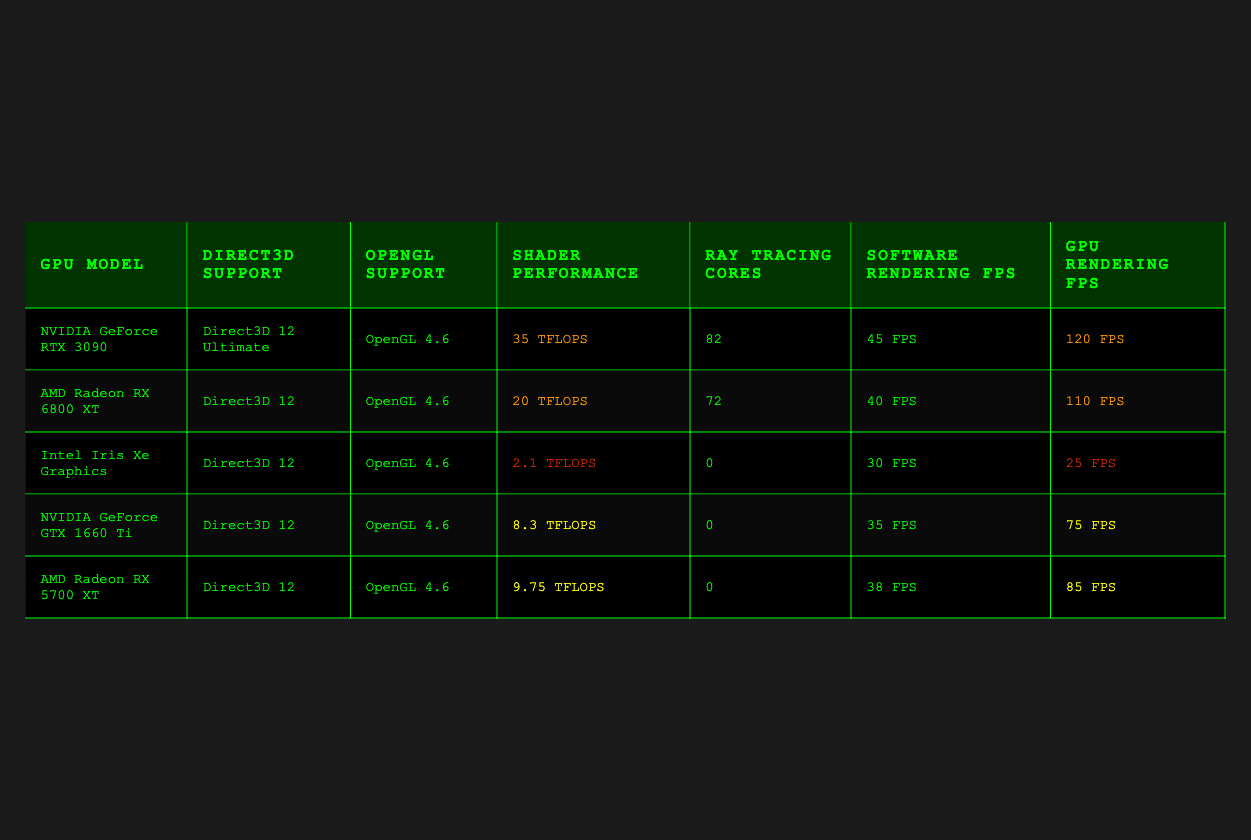What is the shader performance of the NVIDIA GeForce RTX 3090? The table lists the shader performance value directly under the "Shader Performance" column for the NVIDIA GeForce RTX 3090, which is 35 TFLOPS.
Answer: 35 TFLOPS Which GPU has the highest software rendering FPS? To find the highest software rendering FPS, we compare the "Software Rendering FPS" values in the table, where the NVIDIA GeForce RTX 3090 has the highest value at 45 FPS.
Answer: NVIDIA GeForce RTX 3090 What is the difference in GPU rendering FPS between the NVIDIA GeForce RTX 3090 and the Intel Iris Xe Graphics? The GPU rendering FPS for the NVIDIA GeForce RTX 3090 is 120 FPS and for the Intel Iris Xe Graphics, it is 25 FPS. The difference is calculated as 120 - 25 = 95 FPS.
Answer: 95 FPS Do all GPUs listed in the table support Direct3D 12? Checking the "Direct3D Support" column, we see that all GPUs listed either support Direct3D 12 or a higher version. Therefore, the answer is yes.
Answer: Yes Which GPU has the lowest shader performance, and what is its value? By examining the "Shader Performance" column, the Intel Iris Xe Graphics has the lowest value at 2.1 TFLOPS.
Answer: Intel Iris Xe Graphics, 2.1 TFLOPS Calculate the average software rendering FPS of all GPUs listed in the table. To find the average, we sum the software rendering FPS values (45 + 40 + 30 + 35 + 38 = 188) and divide by the number of GPUs (5). So, the average is 188/5 = 37.6 FPS.
Answer: 37.6 FPS Is it true that the AMD Radeon RX 6800 XT has more ray tracing cores than the NVIDIA GeForce GTX 1660 Ti? Comparing the "Ray Tracing Cores" column, the AMD Radeon RX 6800 XT has 72 cores while the NVIDIA GeForce GTX 1660 Ti has 0. Therefore, it is true.
Answer: True What is the total shader performance (in TFLOPS) of all GPUs combined? To find the total, we sum the shader performance values (35 + 20 + 2.1 + 8.3 + 9.75 = 75.15 TFLOPS).
Answer: 75.15 TFLOPS How much better is the GPU rendering performance of the AMD Radeon RX 6800 XT compared to its software rendering performance? The GPU rendering FPS of the AMD Radeon RX 6800 XT is 110 FPS and the software rendering FPS is 40 FPS. The difference is 110 - 40 = 70 FPS, indicating better performance in GPU rendering.
Answer: 70 FPS Which GPU performs the worst in terms of software rendering FPS? By reviewing the "Software Rendering FPS" values, the Intel Iris Xe Graphics has the lowest performance at 30 FPS.
Answer: Intel Iris Xe Graphics, 30 FPS 